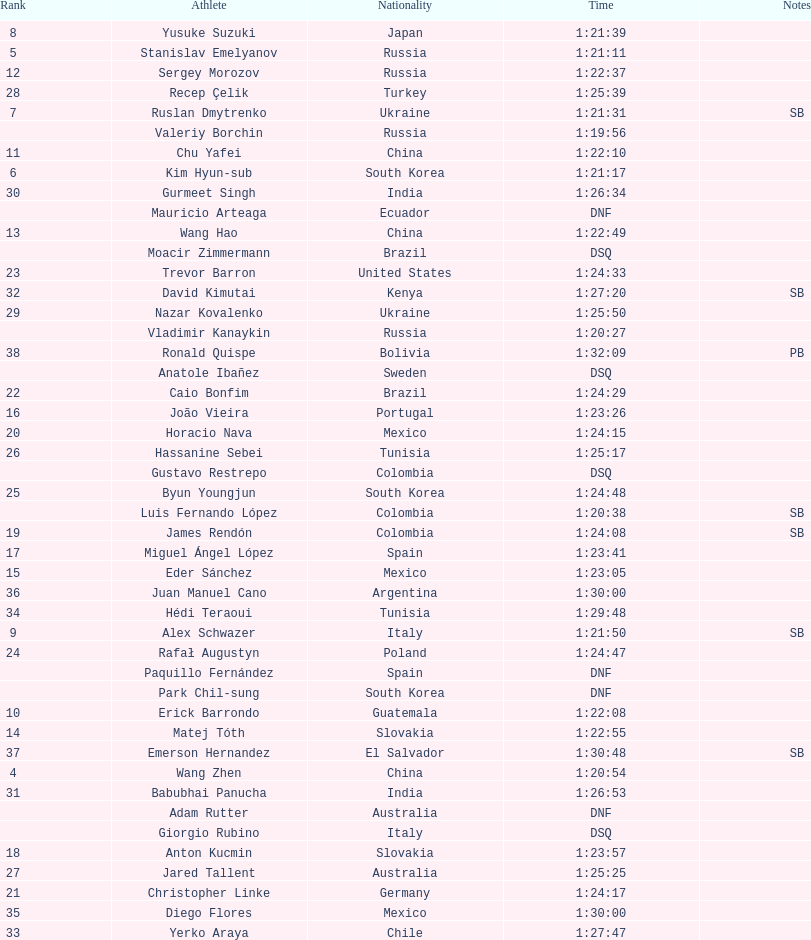Which athlete is the only american to be ranked in the 20km? Trevor Barron. 